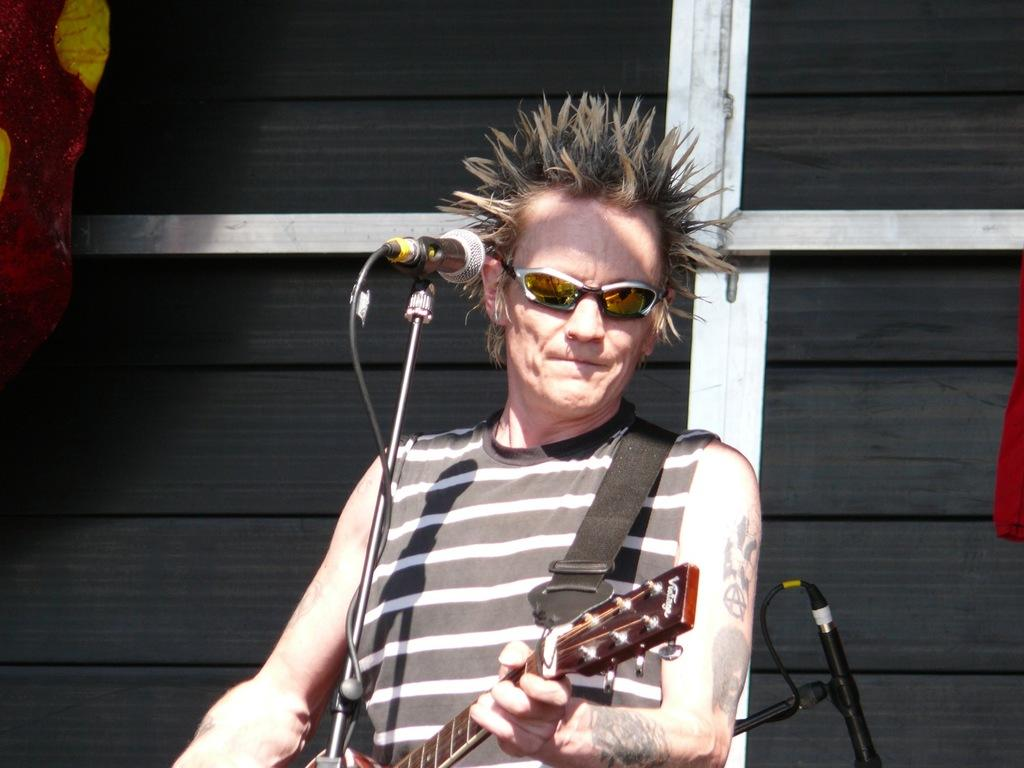What is the man in the image doing? The man is playing the guitar. What object is the man holding in the image? The man is holding a guitar. Where is the man positioned in relation to the microphone? The man is in front of a microphone. What can be seen in the background of the image? There is a black color wood door in the background of the image. What type of waves can be seen crashing on the shore in the image? There are no waves or shore visible in the image; it features a man playing a guitar in front of a microphone. 